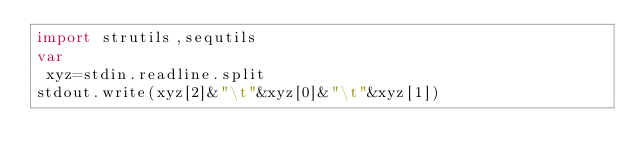<code> <loc_0><loc_0><loc_500><loc_500><_Nim_>import strutils,sequtils
var
 xyz=stdin.readline.split
stdout.write(xyz[2]&"\t"&xyz[0]&"\t"&xyz[1]) </code> 